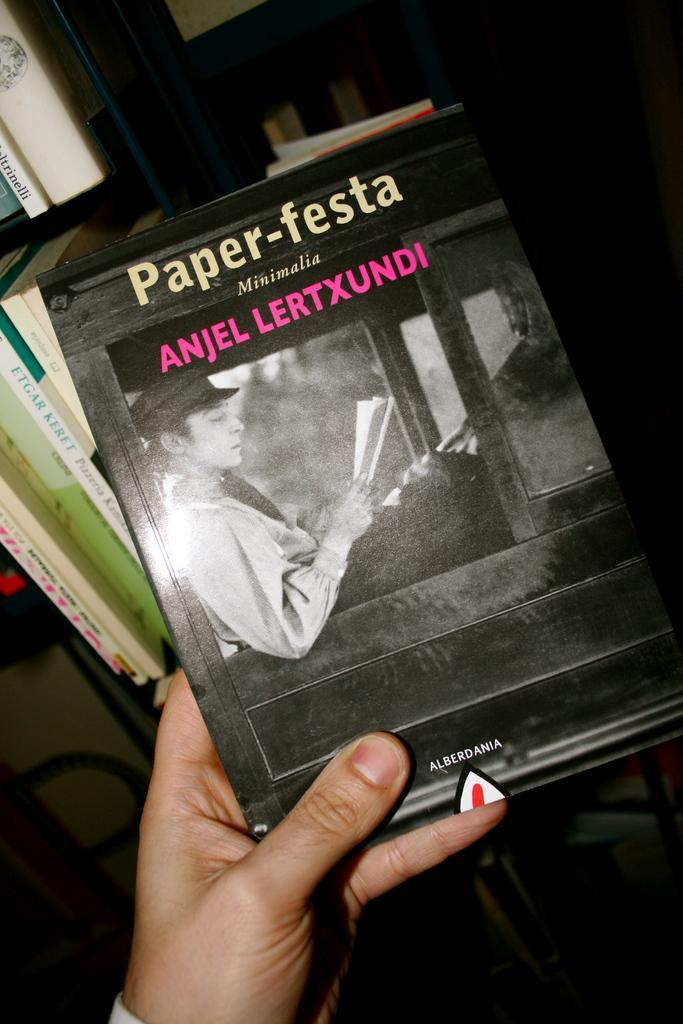Please provide a concise description of this image. In this image we can see there is a person's hand holding a book. And at the back there are racks and books placed in it. 